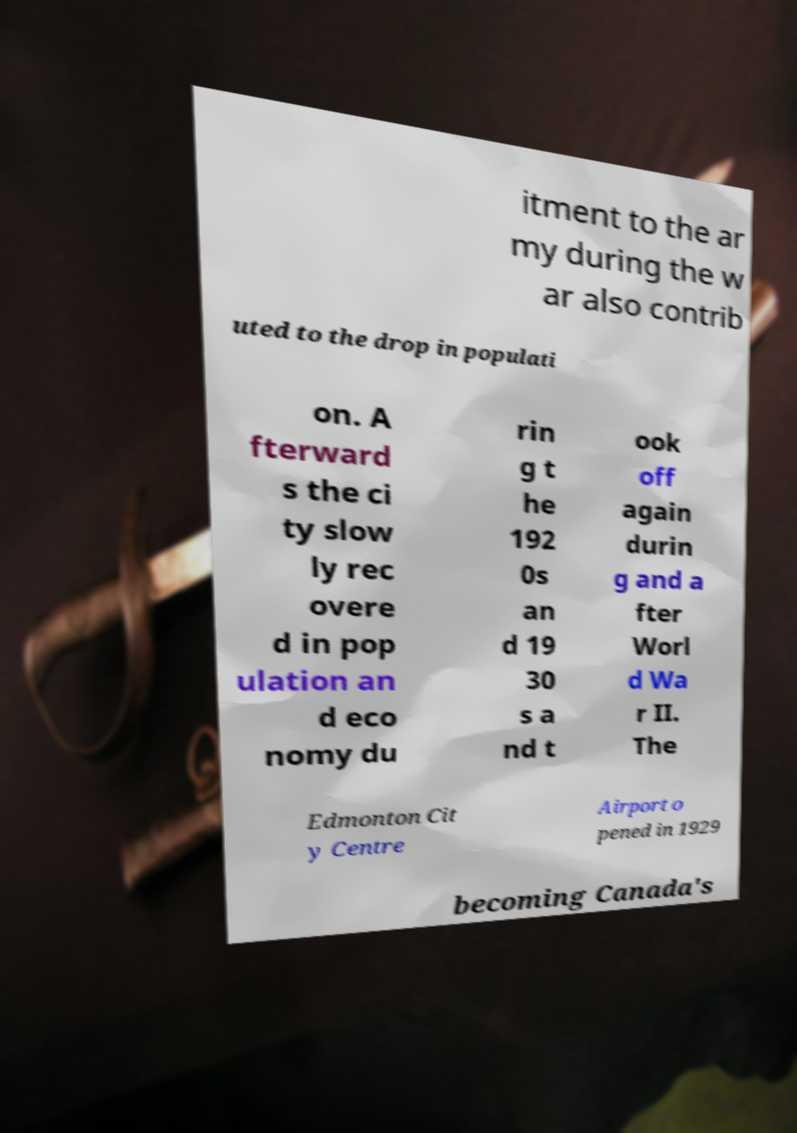Please identify and transcribe the text found in this image. itment to the ar my during the w ar also contrib uted to the drop in populati on. A fterward s the ci ty slow ly rec overe d in pop ulation an d eco nomy du rin g t he 192 0s an d 19 30 s a nd t ook off again durin g and a fter Worl d Wa r II. The Edmonton Cit y Centre Airport o pened in 1929 becoming Canada's 